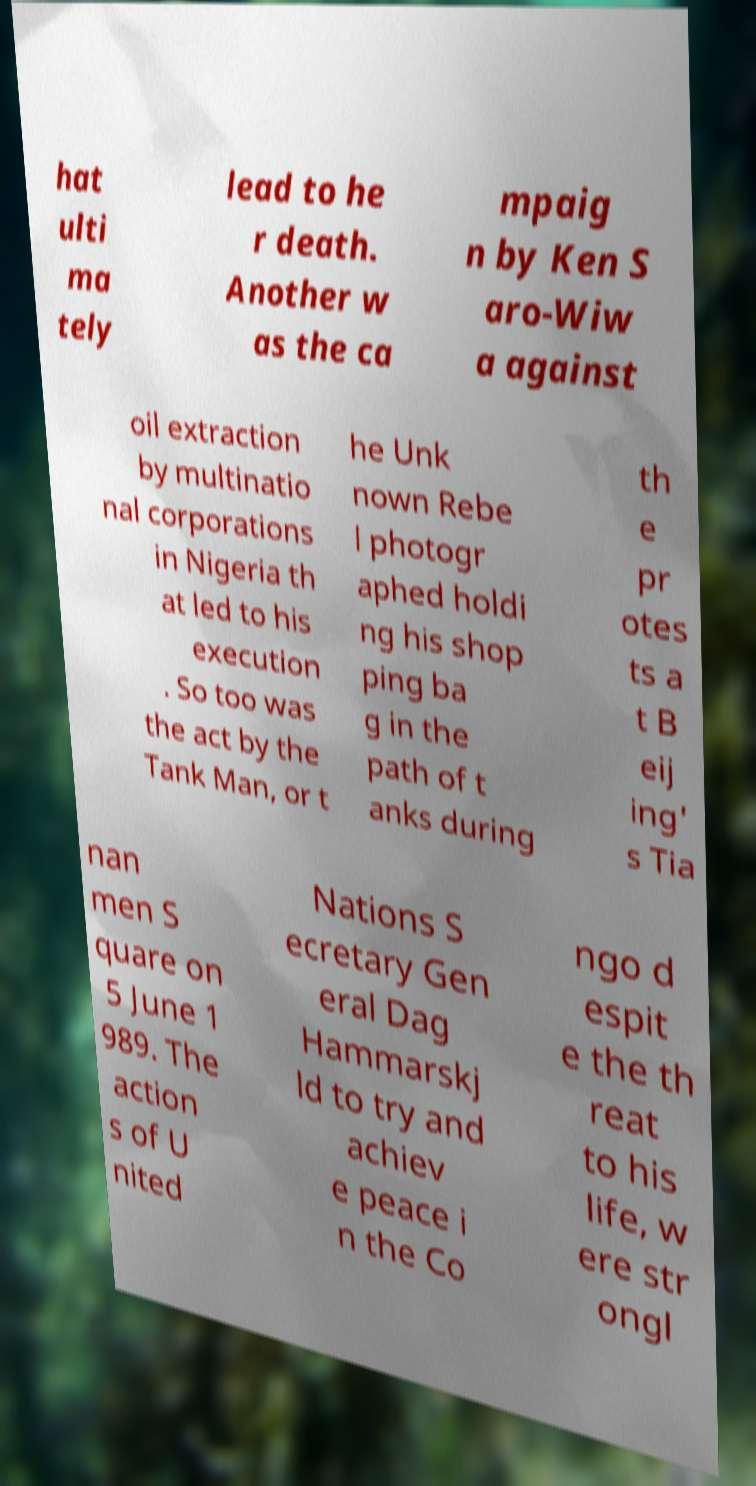Can you read and provide the text displayed in the image?This photo seems to have some interesting text. Can you extract and type it out for me? hat ulti ma tely lead to he r death. Another w as the ca mpaig n by Ken S aro-Wiw a against oil extraction by multinatio nal corporations in Nigeria th at led to his execution . So too was the act by the Tank Man, or t he Unk nown Rebe l photogr aphed holdi ng his shop ping ba g in the path of t anks during th e pr otes ts a t B eij ing' s Tia nan men S quare on 5 June 1 989. The action s of U nited Nations S ecretary Gen eral Dag Hammarskj ld to try and achiev e peace i n the Co ngo d espit e the th reat to his life, w ere str ongl 